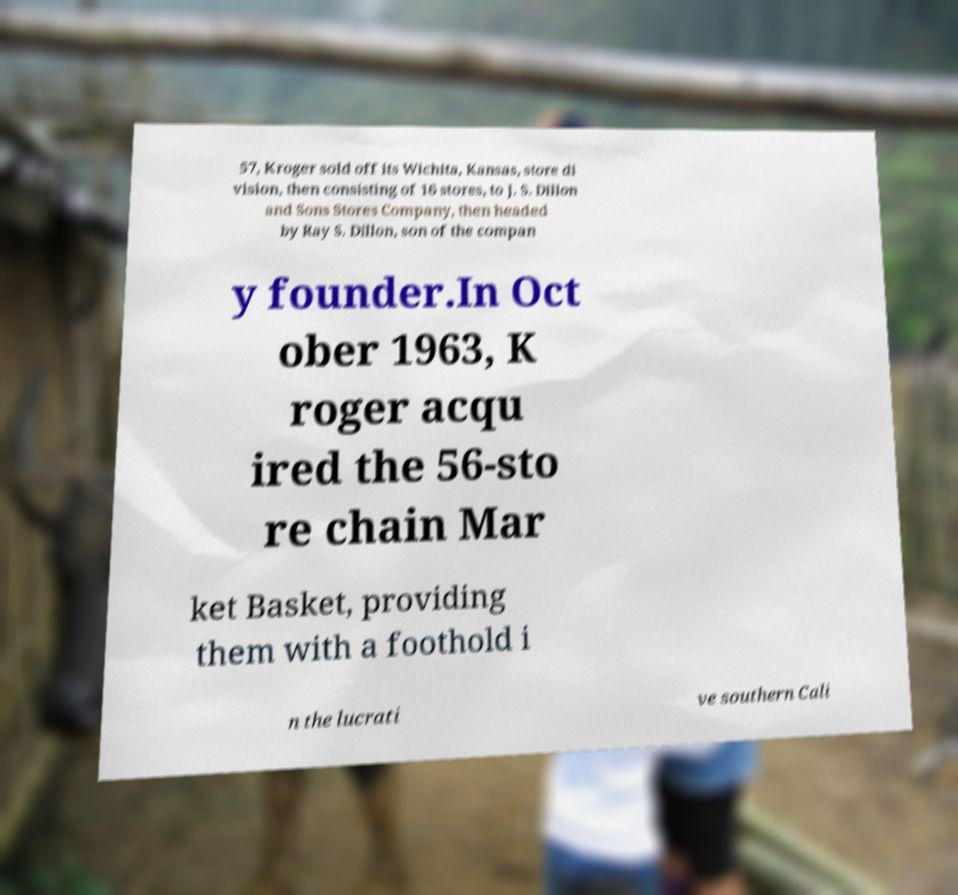Can you accurately transcribe the text from the provided image for me? 57, Kroger sold off its Wichita, Kansas, store di vision, then consisting of 16 stores, to J. S. Dillon and Sons Stores Company, then headed by Ray S. Dillon, son of the compan y founder.In Oct ober 1963, K roger acqu ired the 56-sto re chain Mar ket Basket, providing them with a foothold i n the lucrati ve southern Cali 